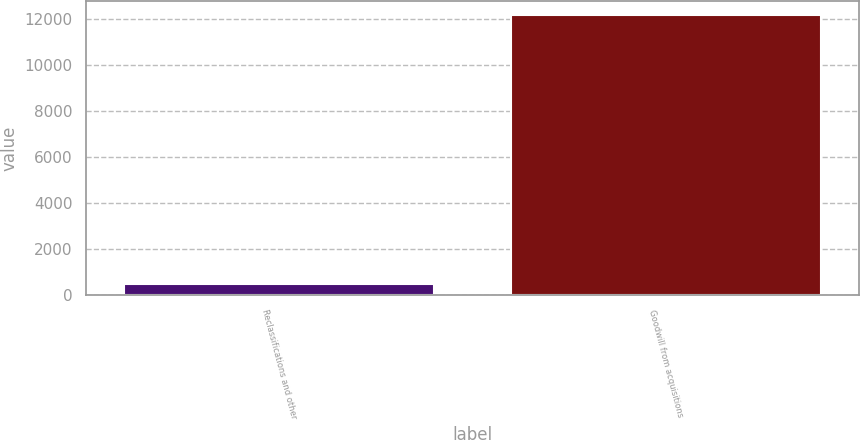Convert chart. <chart><loc_0><loc_0><loc_500><loc_500><bar_chart><fcel>Reclassifications and other<fcel>Goodwill from acquisitions<nl><fcel>516<fcel>12181<nl></chart> 